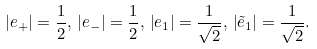<formula> <loc_0><loc_0><loc_500><loc_500>| e _ { + } | = \frac { 1 } { 2 } , \, | e _ { - } | = \frac { 1 } { 2 } , \, \left | e _ { 1 } \right | = \frac { 1 } { \sqrt { 2 } } , \, \left | \tilde { e } _ { 1 } \right | = \frac { 1 } { \sqrt { 2 } } .</formula> 